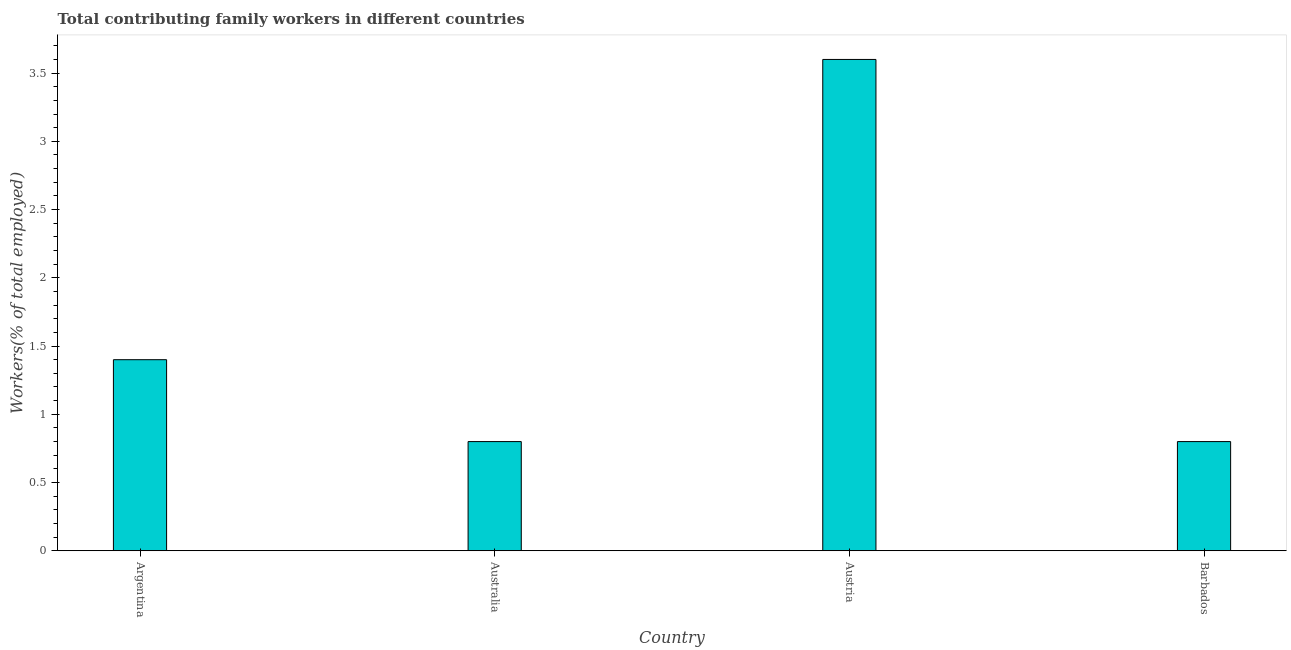What is the title of the graph?
Provide a short and direct response. Total contributing family workers in different countries. What is the label or title of the Y-axis?
Provide a short and direct response. Workers(% of total employed). What is the contributing family workers in Argentina?
Your response must be concise. 1.4. Across all countries, what is the maximum contributing family workers?
Your response must be concise. 3.6. Across all countries, what is the minimum contributing family workers?
Keep it short and to the point. 0.8. In which country was the contributing family workers maximum?
Your answer should be compact. Austria. In which country was the contributing family workers minimum?
Ensure brevity in your answer.  Australia. What is the sum of the contributing family workers?
Provide a succinct answer. 6.6. What is the average contributing family workers per country?
Your response must be concise. 1.65. What is the median contributing family workers?
Give a very brief answer. 1.1. What is the ratio of the contributing family workers in Austria to that in Barbados?
Your answer should be very brief. 4.5. Is the contributing family workers in Argentina less than that in Austria?
Ensure brevity in your answer.  Yes. Is the difference between the contributing family workers in Argentina and Australia greater than the difference between any two countries?
Give a very brief answer. No. What is the difference between the highest and the second highest contributing family workers?
Your answer should be compact. 2.2. Is the sum of the contributing family workers in Argentina and Australia greater than the maximum contributing family workers across all countries?
Offer a terse response. No. How many bars are there?
Your answer should be very brief. 4. Are all the bars in the graph horizontal?
Give a very brief answer. No. What is the difference between two consecutive major ticks on the Y-axis?
Provide a short and direct response. 0.5. Are the values on the major ticks of Y-axis written in scientific E-notation?
Your answer should be compact. No. What is the Workers(% of total employed) of Argentina?
Your response must be concise. 1.4. What is the Workers(% of total employed) in Australia?
Keep it short and to the point. 0.8. What is the Workers(% of total employed) of Austria?
Make the answer very short. 3.6. What is the Workers(% of total employed) of Barbados?
Make the answer very short. 0.8. What is the difference between the Workers(% of total employed) in Argentina and Austria?
Give a very brief answer. -2.2. What is the difference between the Workers(% of total employed) in Australia and Austria?
Ensure brevity in your answer.  -2.8. What is the difference between the Workers(% of total employed) in Australia and Barbados?
Offer a very short reply. 0. What is the ratio of the Workers(% of total employed) in Argentina to that in Australia?
Provide a short and direct response. 1.75. What is the ratio of the Workers(% of total employed) in Argentina to that in Austria?
Make the answer very short. 0.39. What is the ratio of the Workers(% of total employed) in Australia to that in Austria?
Your response must be concise. 0.22. What is the ratio of the Workers(% of total employed) in Austria to that in Barbados?
Your response must be concise. 4.5. 